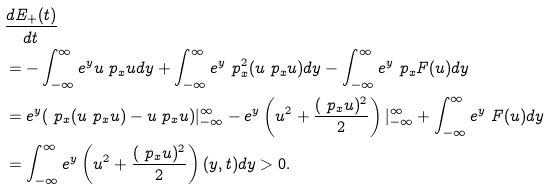<formula> <loc_0><loc_0><loc_500><loc_500>& \frac { d E _ { + } ( t ) } { d t \, } \\ & = - \int _ { - \infty } ^ { \infty } e ^ { y } u \ p _ { x } u d y + \int _ { - \infty } ^ { \infty } e ^ { y } \ p _ { x } ^ { 2 } ( u \ p _ { x } u ) d y - \int _ { - \infty } ^ { \infty } e ^ { y } \ p _ { x } F ( u ) d y \\ & = e ^ { y } ( \ p _ { x } ( u \ p _ { x } u ) - u \ p _ { x } u ) | _ { - \infty } ^ { \infty } - e ^ { y } \left ( u ^ { 2 } + \frac { ( \ p _ { x } u ) ^ { 2 } } { 2 } \right ) | _ { - \infty } ^ { \infty } + \int _ { - \infty } ^ { \infty } e ^ { y } \ F ( u ) d y \\ & = \int _ { - \infty } ^ { \infty } e ^ { y } \left ( u ^ { 2 } + \frac { ( \ p _ { x } u ) ^ { 2 } } { 2 } \right ) ( y , t ) d y > 0 .</formula> 